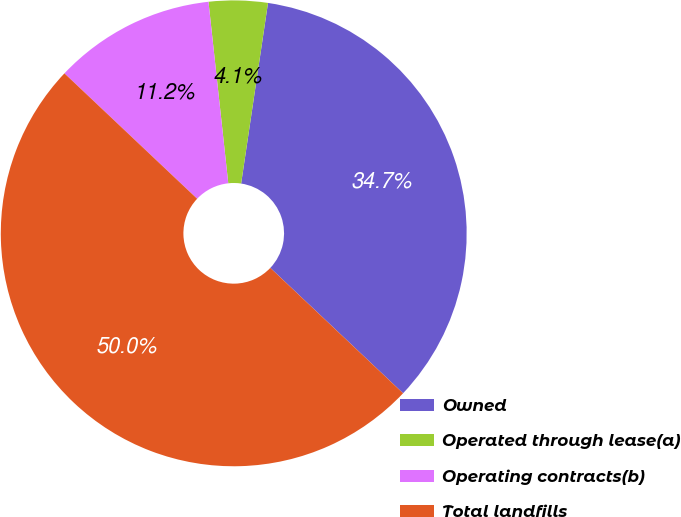<chart> <loc_0><loc_0><loc_500><loc_500><pie_chart><fcel>Owned<fcel>Operated through lease(a)<fcel>Operating contracts(b)<fcel>Total landfills<nl><fcel>34.69%<fcel>4.08%<fcel>11.22%<fcel>50.0%<nl></chart> 